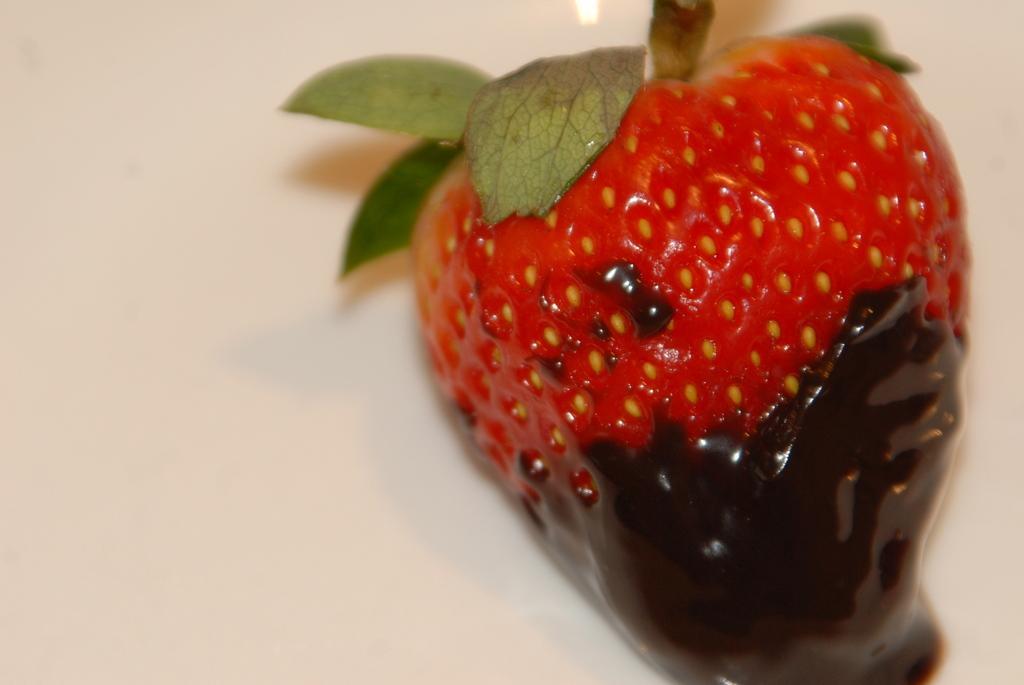Describe this image in one or two sentences. In this picture there is a strawberry and there are leaves and there is a cream on the strawberry. At the bottom there is a white background. 